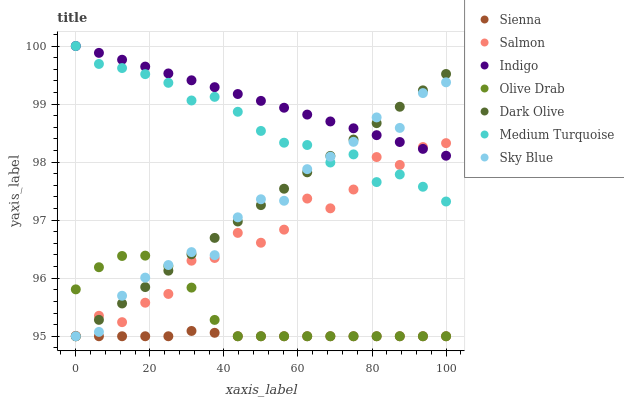Does Sienna have the minimum area under the curve?
Answer yes or no. Yes. Does Indigo have the maximum area under the curve?
Answer yes or no. Yes. Does Dark Olive have the minimum area under the curve?
Answer yes or no. No. Does Dark Olive have the maximum area under the curve?
Answer yes or no. No. Is Indigo the smoothest?
Answer yes or no. Yes. Is Salmon the roughest?
Answer yes or no. Yes. Is Dark Olive the smoothest?
Answer yes or no. No. Is Dark Olive the roughest?
Answer yes or no. No. Does Dark Olive have the lowest value?
Answer yes or no. Yes. Does Salmon have the lowest value?
Answer yes or no. No. Does Medium Turquoise have the highest value?
Answer yes or no. Yes. Does Dark Olive have the highest value?
Answer yes or no. No. Is Sienna less than Medium Turquoise?
Answer yes or no. Yes. Is Medium Turquoise greater than Olive Drab?
Answer yes or no. Yes. Does Olive Drab intersect Salmon?
Answer yes or no. Yes. Is Olive Drab less than Salmon?
Answer yes or no. No. Is Olive Drab greater than Salmon?
Answer yes or no. No. Does Sienna intersect Medium Turquoise?
Answer yes or no. No. 